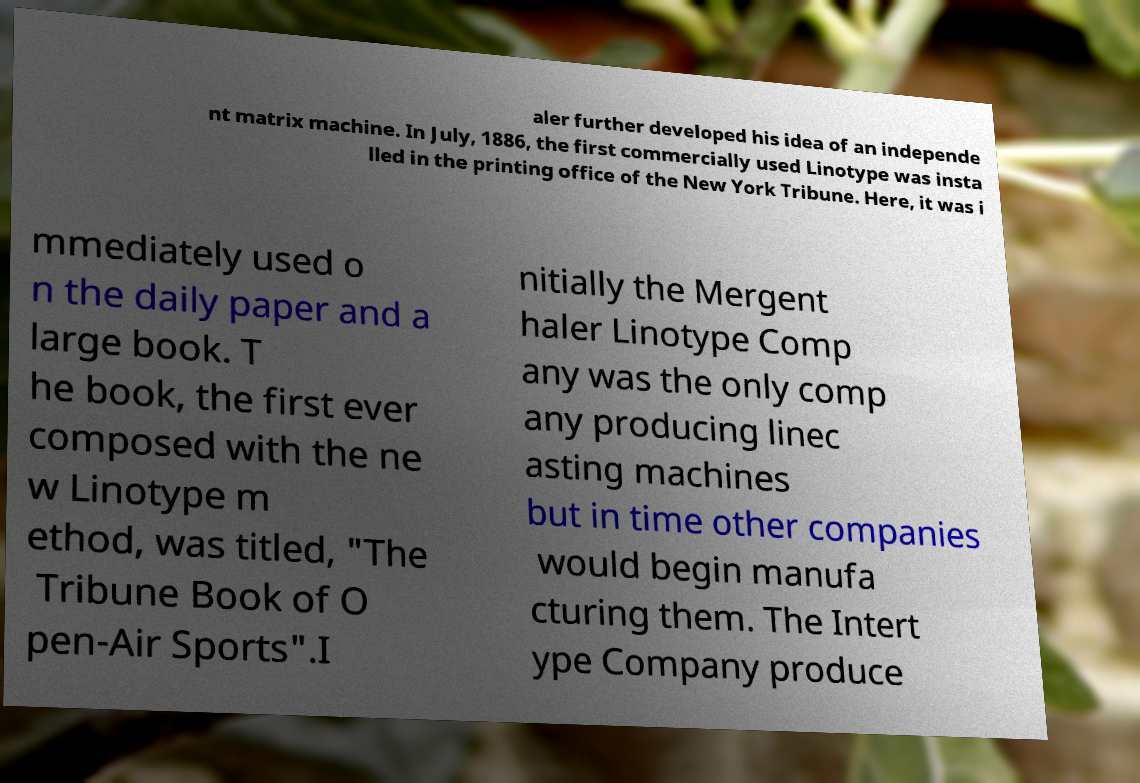Can you read and provide the text displayed in the image?This photo seems to have some interesting text. Can you extract and type it out for me? aler further developed his idea of an independe nt matrix machine. In July, 1886, the first commercially used Linotype was insta lled in the printing office of the New York Tribune. Here, it was i mmediately used o n the daily paper and a large book. T he book, the first ever composed with the ne w Linotype m ethod, was titled, "The Tribune Book of O pen-Air Sports".I nitially the Mergent haler Linotype Comp any was the only comp any producing linec asting machines but in time other companies would begin manufa cturing them. The Intert ype Company produce 